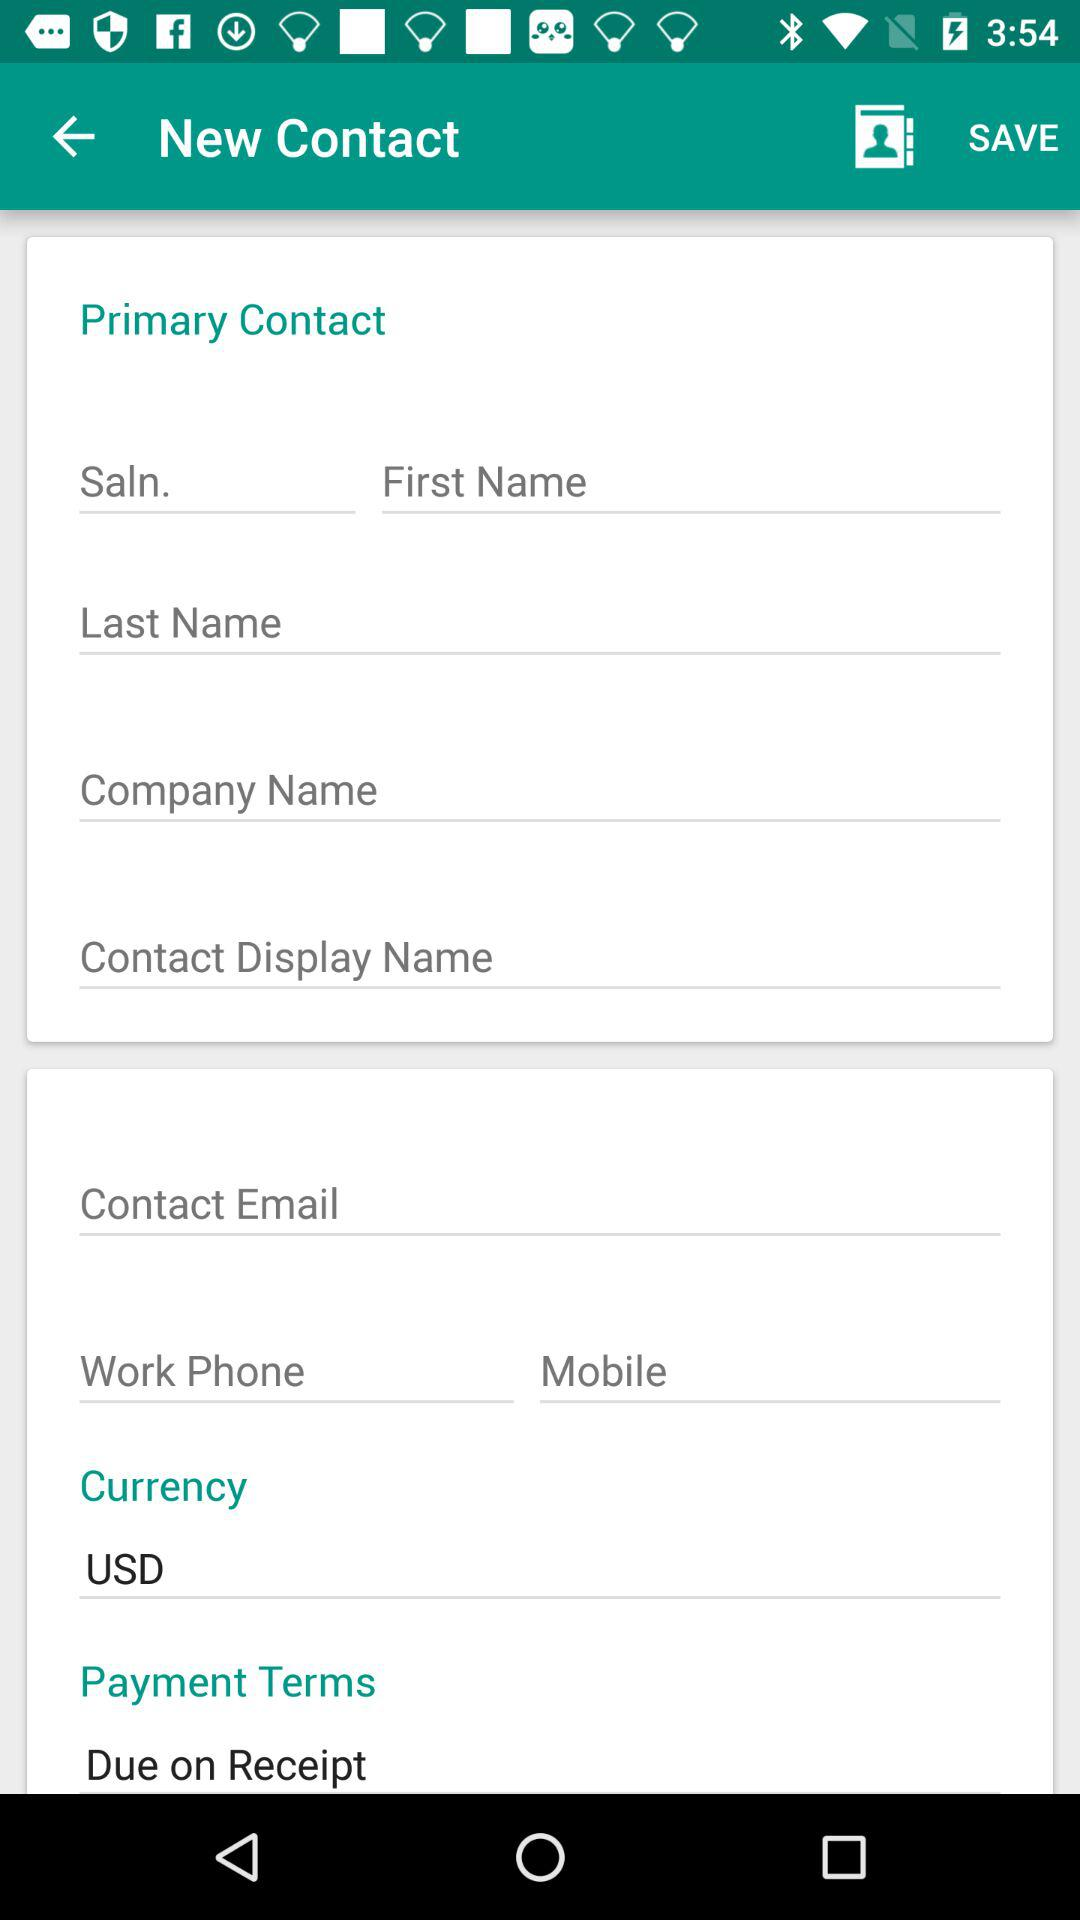What is the currency that is being used? The currency being used is the USD. 